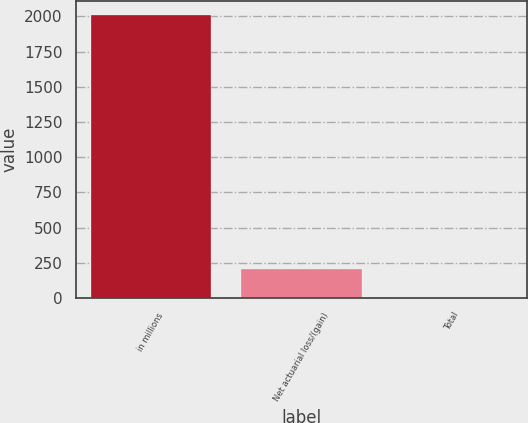Convert chart. <chart><loc_0><loc_0><loc_500><loc_500><bar_chart><fcel>in millions<fcel>Net actuarial loss/(gain)<fcel>Total<nl><fcel>2010<fcel>201.72<fcel>0.8<nl></chart> 